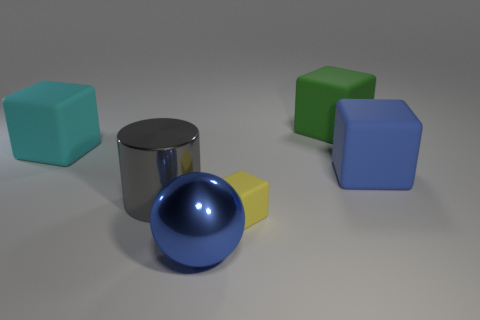Subtract all blue matte blocks. How many blocks are left? 3 Add 4 rubber cubes. How many rubber cubes exist? 8 Add 1 yellow matte cubes. How many objects exist? 7 Subtract all yellow blocks. How many blocks are left? 3 Subtract 1 blue balls. How many objects are left? 5 Subtract all cubes. How many objects are left? 2 Subtract 1 cylinders. How many cylinders are left? 0 Subtract all cyan cylinders. Subtract all blue balls. How many cylinders are left? 1 Subtract all gray spheres. How many purple cylinders are left? 0 Subtract all green matte spheres. Subtract all yellow things. How many objects are left? 5 